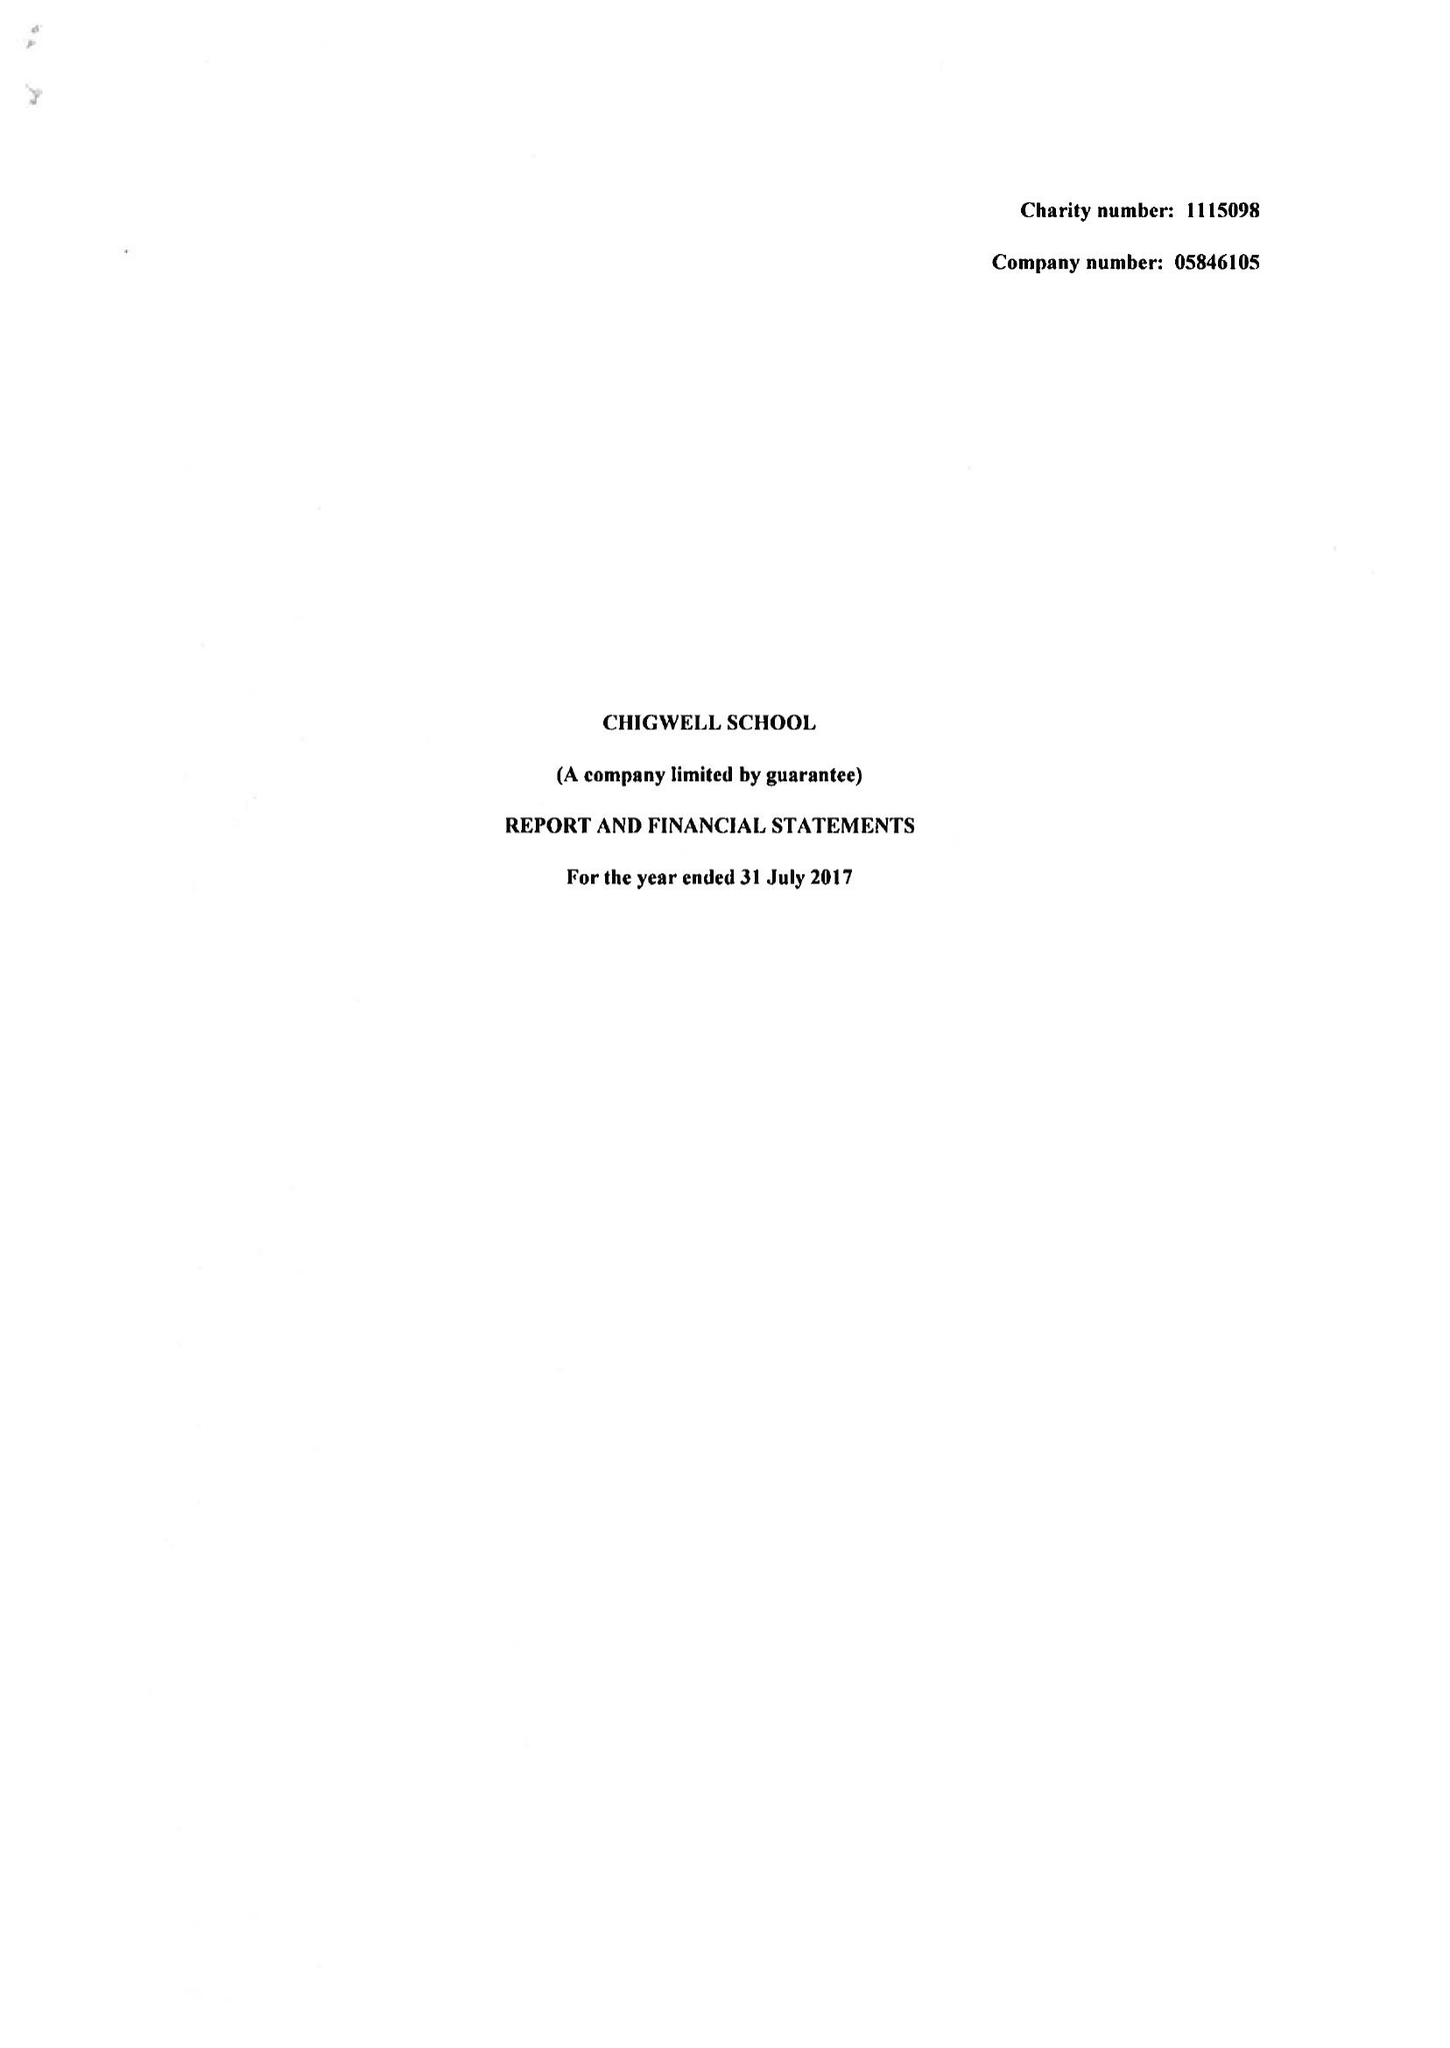What is the value for the report_date?
Answer the question using a single word or phrase. 2017-07-31 